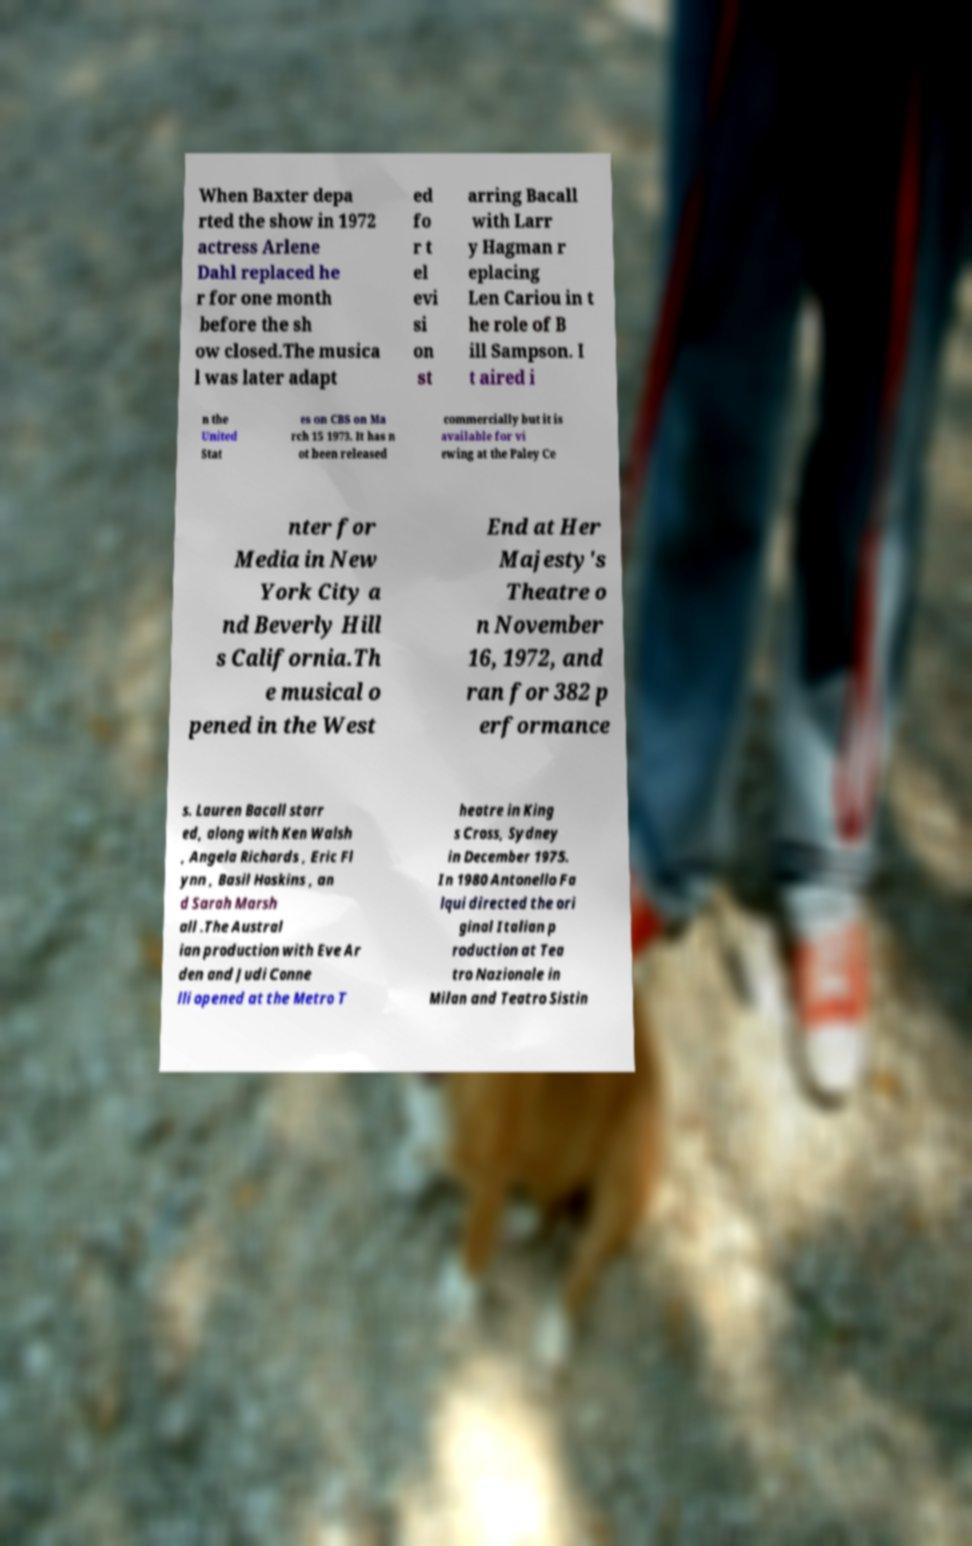Please read and relay the text visible in this image. What does it say? When Baxter depa rted the show in 1972 actress Arlene Dahl replaced he r for one month before the sh ow closed.The musica l was later adapt ed fo r t el evi si on st arring Bacall with Larr y Hagman r eplacing Len Cariou in t he role of B ill Sampson. I t aired i n the United Stat es on CBS on Ma rch 15 1973. It has n ot been released commercially but it is available for vi ewing at the Paley Ce nter for Media in New York City a nd Beverly Hill s California.Th e musical o pened in the West End at Her Majesty's Theatre o n November 16, 1972, and ran for 382 p erformance s. Lauren Bacall starr ed, along with Ken Walsh , Angela Richards , Eric Fl ynn , Basil Hoskins , an d Sarah Marsh all .The Austral ian production with Eve Ar den and Judi Conne lli opened at the Metro T heatre in King s Cross, Sydney in December 1975. In 1980 Antonello Fa lqui directed the ori ginal Italian p roduction at Tea tro Nazionale in Milan and Teatro Sistin 